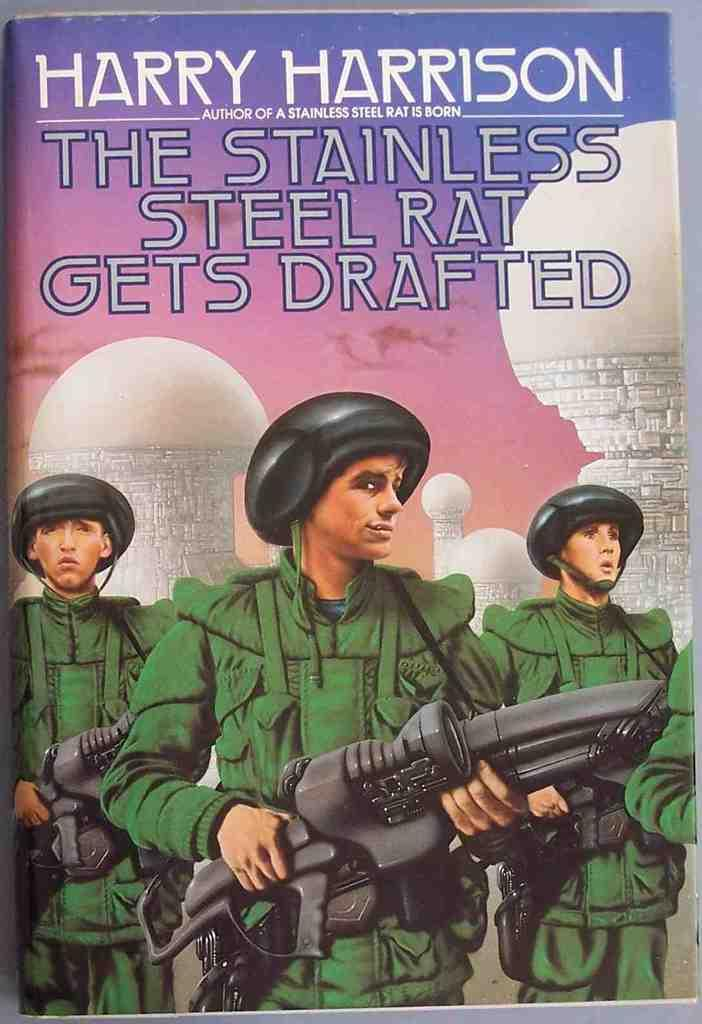<image>
Describe the image concisely. A book by Harry Harrison with soldiers on the cover. 